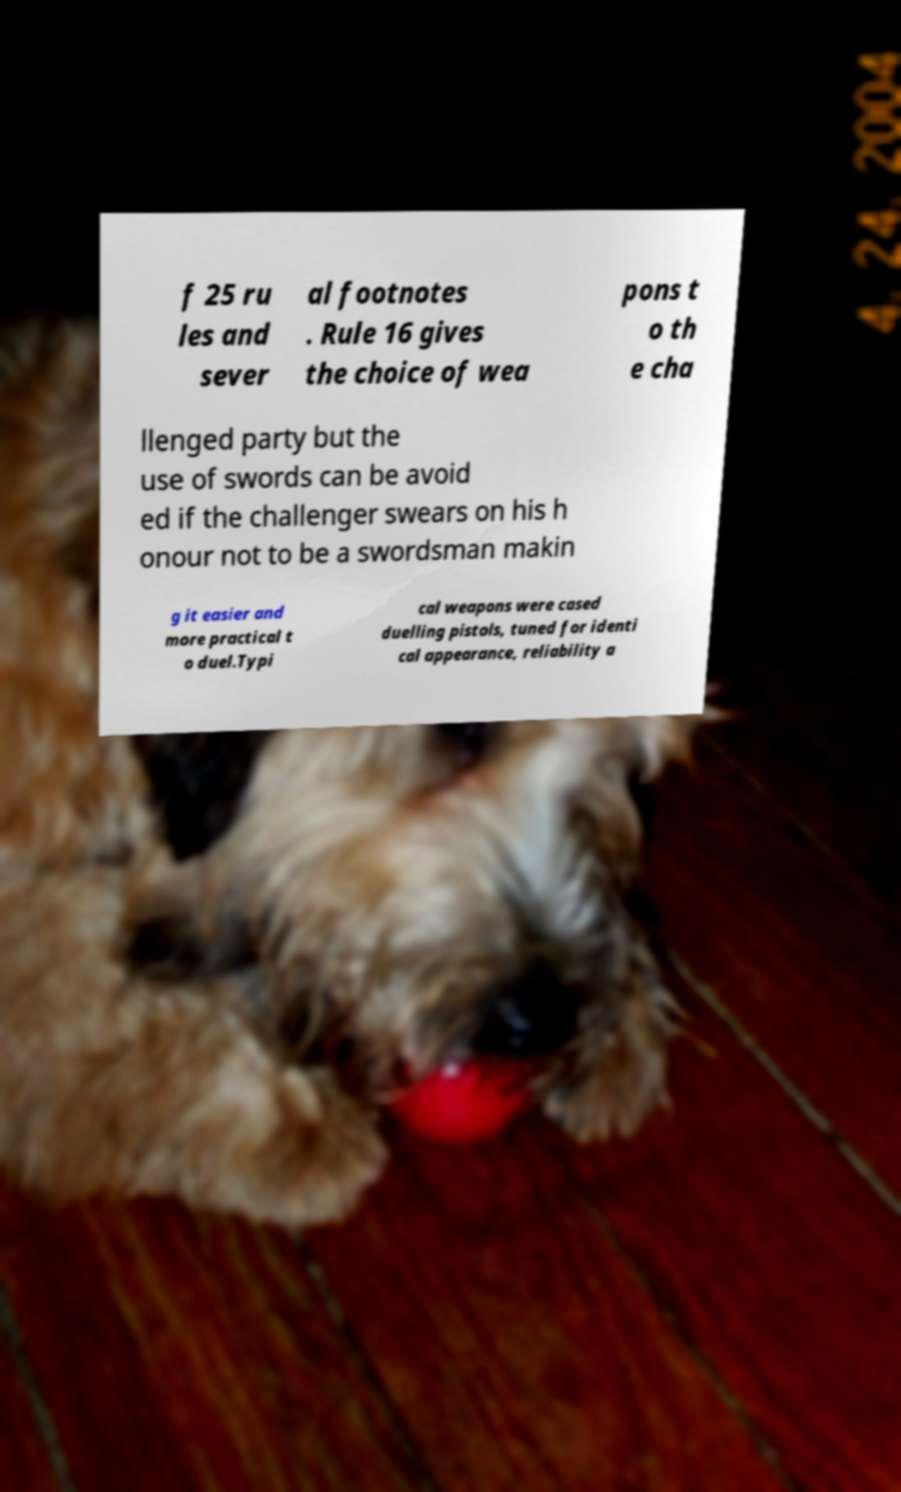For documentation purposes, I need the text within this image transcribed. Could you provide that? f 25 ru les and sever al footnotes . Rule 16 gives the choice of wea pons t o th e cha llenged party but the use of swords can be avoid ed if the challenger swears on his h onour not to be a swordsman makin g it easier and more practical t o duel.Typi cal weapons were cased duelling pistols, tuned for identi cal appearance, reliability a 